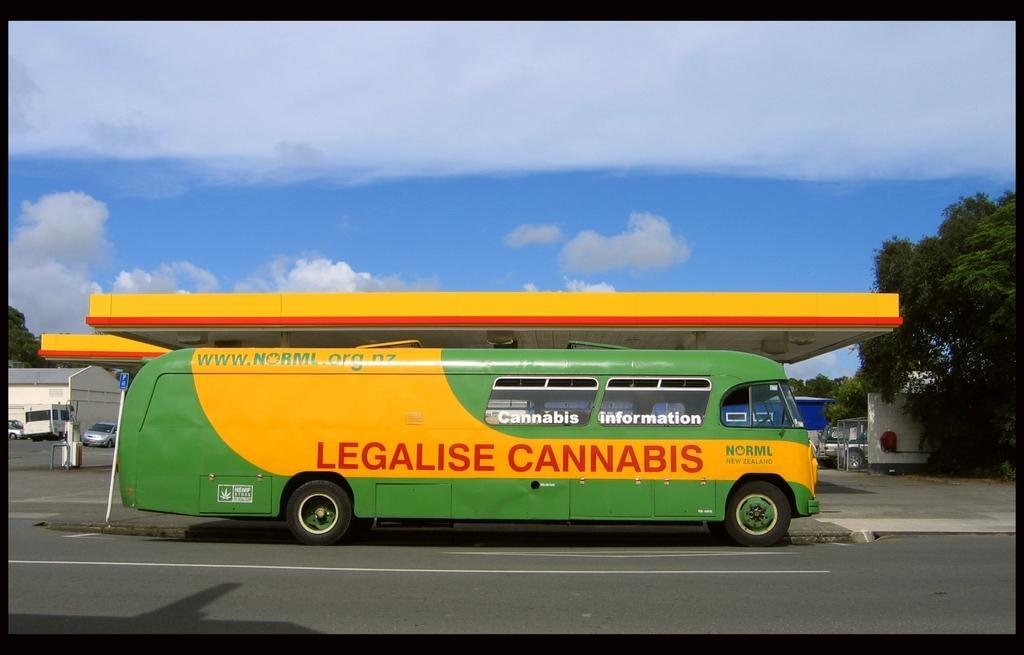How would you summarize this image in a sentence or two? In this picture we can see vehicles on the road, roof, building, trees, some objects and in the background we can see the sky with clouds. 